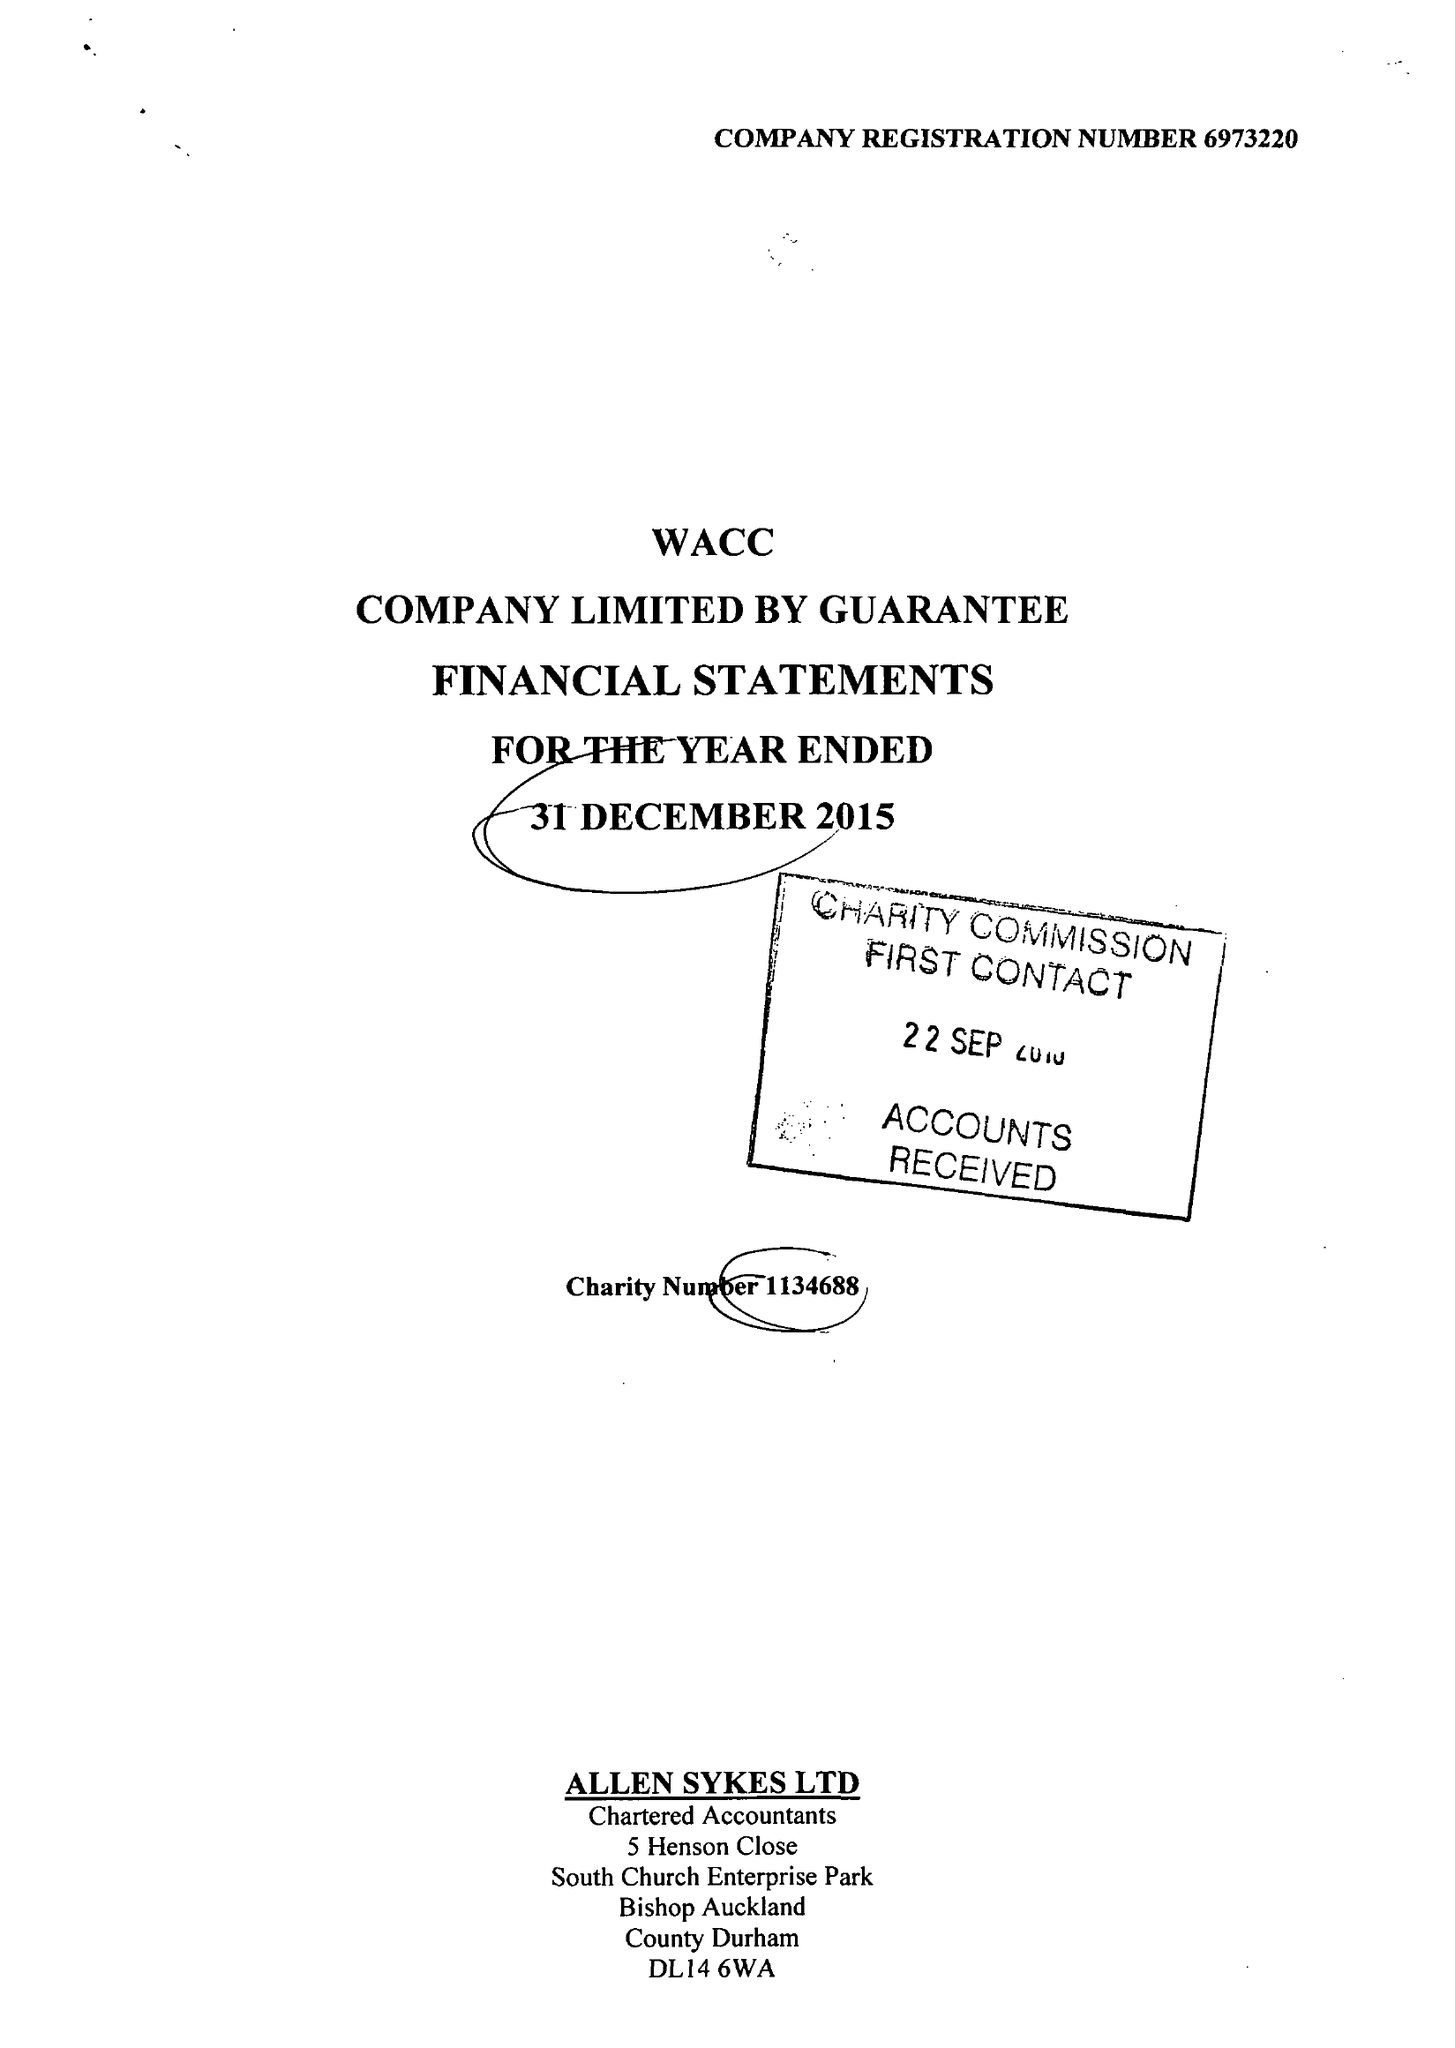What is the value for the address__street_line?
Answer the question using a single word or phrase. None 